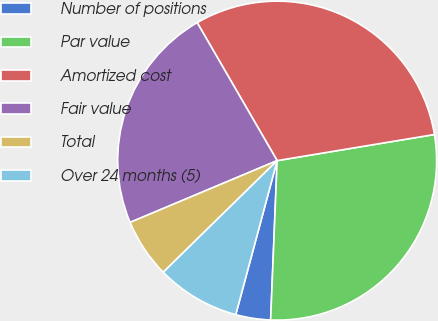Convert chart to OTSL. <chart><loc_0><loc_0><loc_500><loc_500><pie_chart><fcel>Number of positions<fcel>Par value<fcel>Amortized cost<fcel>Fair value<fcel>Total<fcel>Over 24 months (5)<nl><fcel>3.53%<fcel>28.27%<fcel>30.74%<fcel>22.97%<fcel>6.01%<fcel>8.48%<nl></chart> 